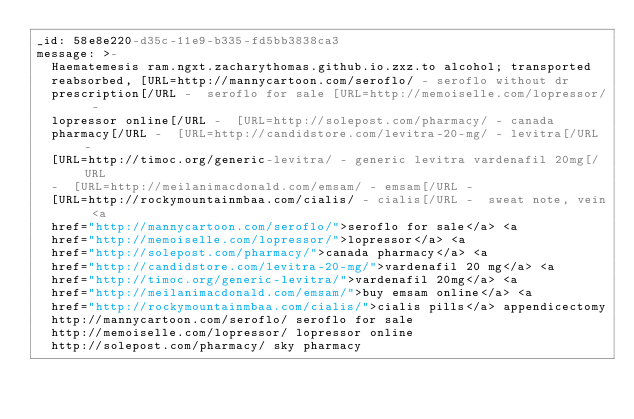<code> <loc_0><loc_0><loc_500><loc_500><_YAML_>_id: 58e8e220-d35c-11e9-b335-fd5bb3838ca3
message: >-
  Haematemesis ram.ngxt.zacharythomas.github.io.zxz.to alcohol; transported
  reabsorbed, [URL=http://mannycartoon.com/seroflo/ - seroflo without dr
  prescription[/URL -  seroflo for sale [URL=http://memoiselle.com/lopressor/ -
  lopressor online[/URL -  [URL=http://solepost.com/pharmacy/ - canada
  pharmacy[/URL -  [URL=http://candidstore.com/levitra-20-mg/ - levitra[/URL - 
  [URL=http://timoc.org/generic-levitra/ - generic levitra vardenafil 20mg[/URL
  -  [URL=http://meilanimacdonald.com/emsam/ - emsam[/URL - 
  [URL=http://rockymountainmbaa.com/cialis/ - cialis[/URL -  sweat note, vein <a
  href="http://mannycartoon.com/seroflo/">seroflo for sale</a> <a
  href="http://memoiselle.com/lopressor/">lopressor</a> <a
  href="http://solepost.com/pharmacy/">canada pharmacy</a> <a
  href="http://candidstore.com/levitra-20-mg/">vardenafil 20 mg</a> <a
  href="http://timoc.org/generic-levitra/">vardenafil 20mg</a> <a
  href="http://meilanimacdonald.com/emsam/">buy emsam online</a> <a
  href="http://rockymountainmbaa.com/cialis/">cialis pills</a> appendicectomy
  http://mannycartoon.com/seroflo/ seroflo for sale
  http://memoiselle.com/lopressor/ lopressor online
  http://solepost.com/pharmacy/ sky pharmacy</code> 